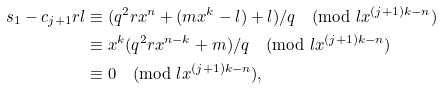Convert formula to latex. <formula><loc_0><loc_0><loc_500><loc_500>s _ { 1 } - c _ { j + 1 } r l & \equiv ( q ^ { 2 } r x ^ { n } + ( m x ^ { k } - l ) + l ) / q \pmod { l x ^ { ( j + 1 ) k - n } } \\ & \equiv x ^ { k } ( q ^ { 2 } r x ^ { n - k } + m ) / q \pmod { l x ^ { ( j + 1 ) k - n } } \\ & \equiv 0 \pmod { l x ^ { ( j + 1 ) k - n } } ,</formula> 